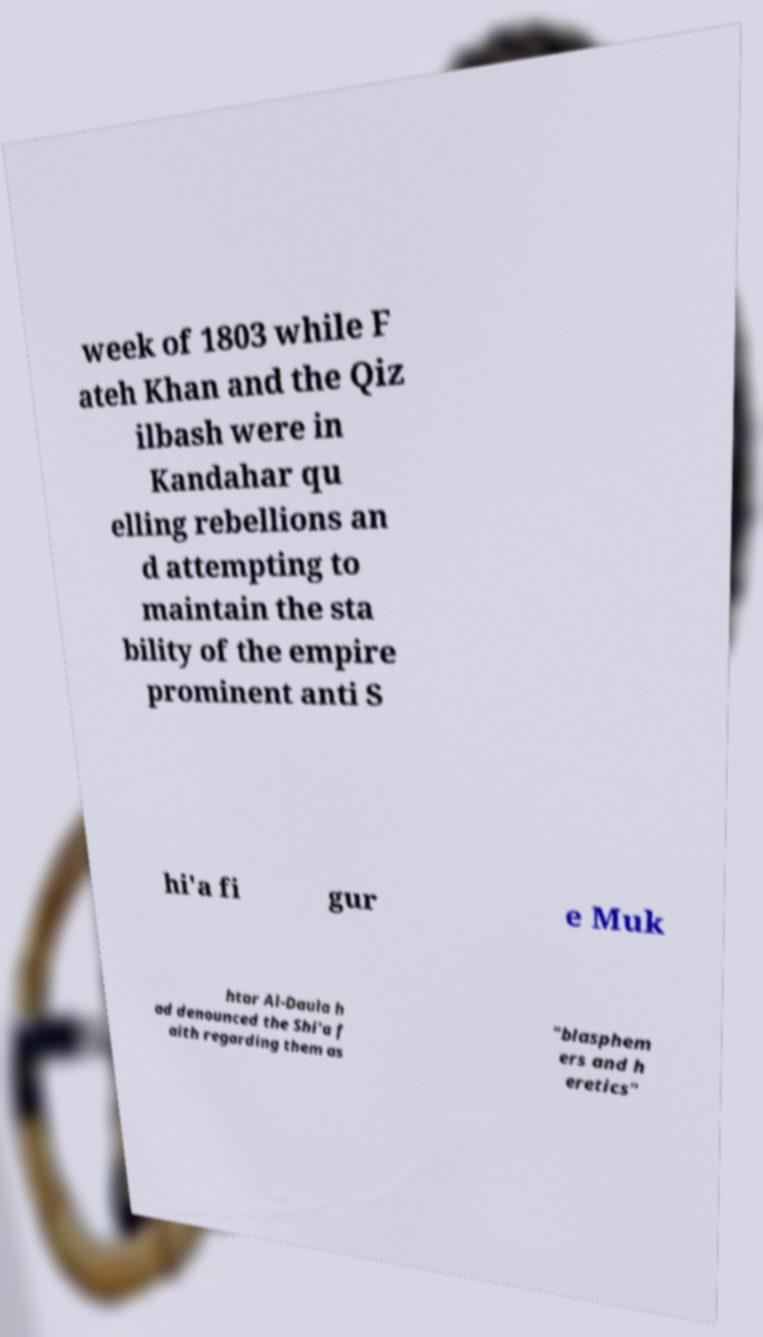Can you accurately transcribe the text from the provided image for me? week of 1803 while F ateh Khan and the Qiz ilbash were in Kandahar qu elling rebellions an d attempting to maintain the sta bility of the empire prominent anti S hi'a fi gur e Muk htar Al-Daula h ad denounced the Shi'a f aith regarding them as "blasphem ers and h eretics" 